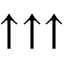<formula> <loc_0><loc_0><loc_500><loc_500>\uparrow \uparrow \uparrow</formula> 